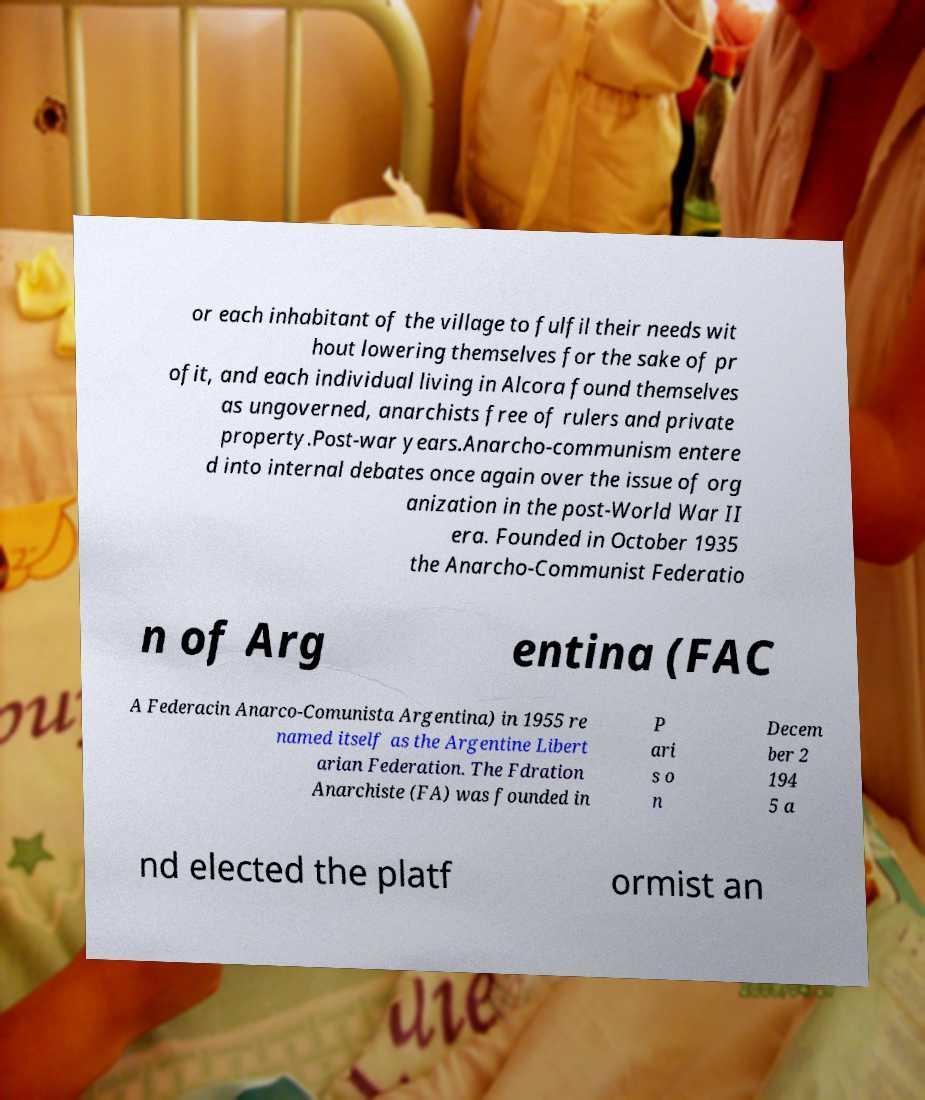For documentation purposes, I need the text within this image transcribed. Could you provide that? or each inhabitant of the village to fulfil their needs wit hout lowering themselves for the sake of pr ofit, and each individual living in Alcora found themselves as ungoverned, anarchists free of rulers and private property.Post-war years.Anarcho-communism entere d into internal debates once again over the issue of org anization in the post-World War II era. Founded in October 1935 the Anarcho-Communist Federatio n of Arg entina (FAC A Federacin Anarco-Comunista Argentina) in 1955 re named itself as the Argentine Libert arian Federation. The Fdration Anarchiste (FA) was founded in P ari s o n Decem ber 2 194 5 a nd elected the platf ormist an 